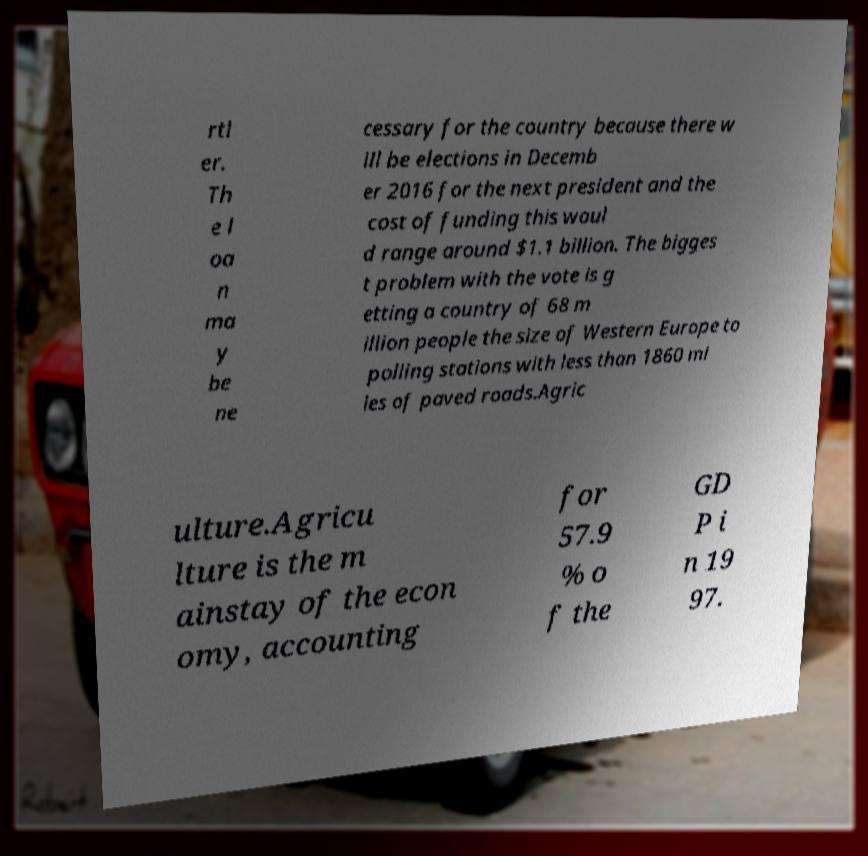Please read and relay the text visible in this image. What does it say? rtl er. Th e l oa n ma y be ne cessary for the country because there w ill be elections in Decemb er 2016 for the next president and the cost of funding this woul d range around $1.1 billion. The bigges t problem with the vote is g etting a country of 68 m illion people the size of Western Europe to polling stations with less than 1860 mi les of paved roads.Agric ulture.Agricu lture is the m ainstay of the econ omy, accounting for 57.9 % o f the GD P i n 19 97. 